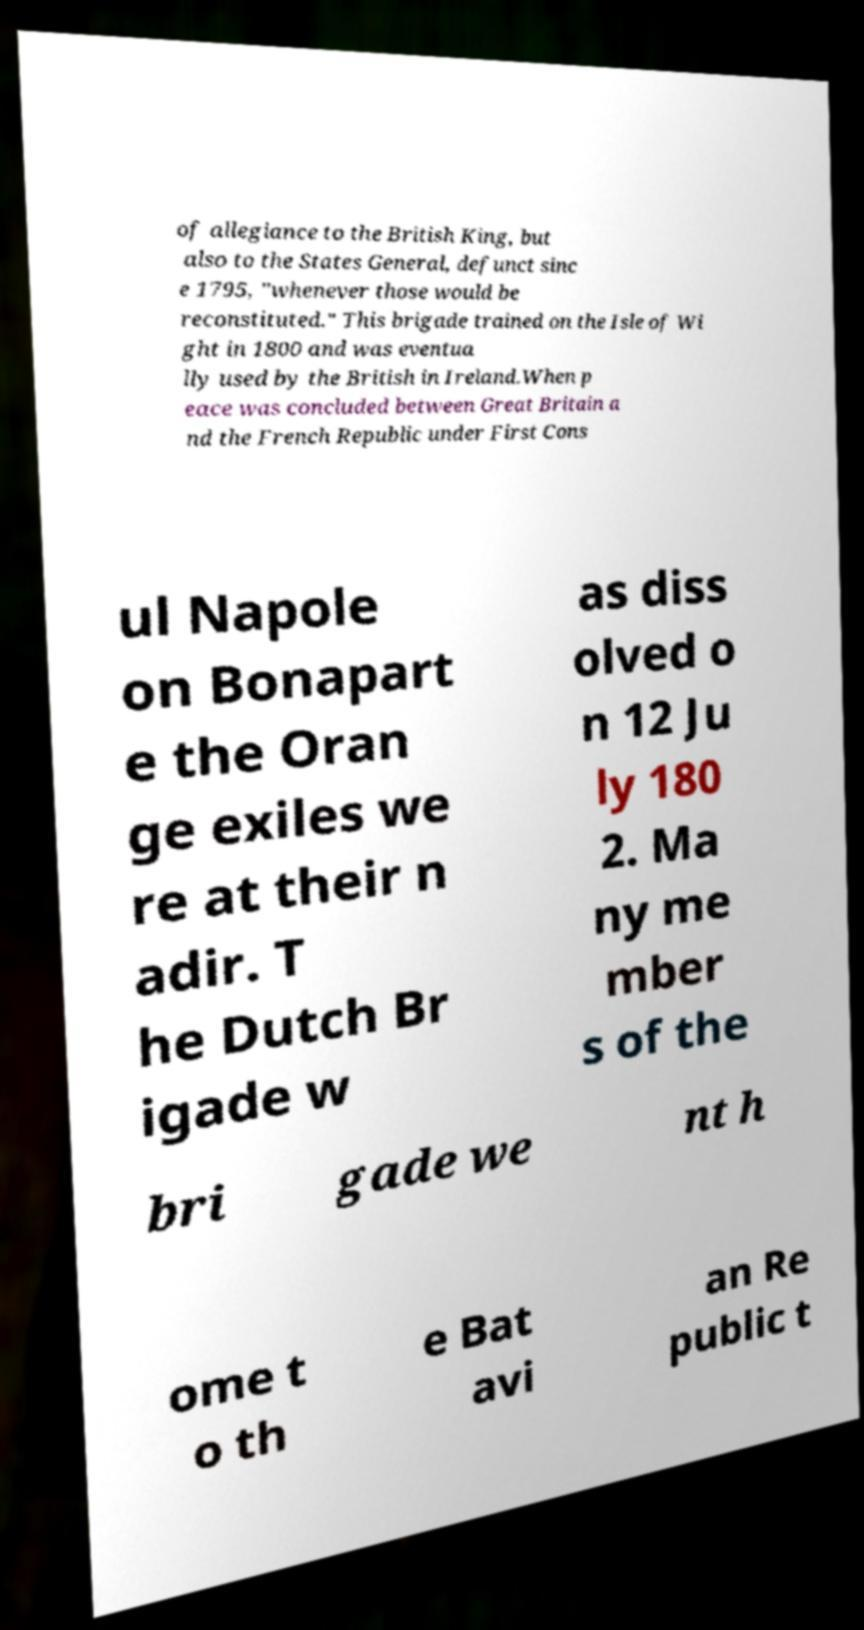There's text embedded in this image that I need extracted. Can you transcribe it verbatim? of allegiance to the British King, but also to the States General, defunct sinc e 1795, "whenever those would be reconstituted." This brigade trained on the Isle of Wi ght in 1800 and was eventua lly used by the British in Ireland.When p eace was concluded between Great Britain a nd the French Republic under First Cons ul Napole on Bonapart e the Oran ge exiles we re at their n adir. T he Dutch Br igade w as diss olved o n 12 Ju ly 180 2. Ma ny me mber s of the bri gade we nt h ome t o th e Bat avi an Re public t 